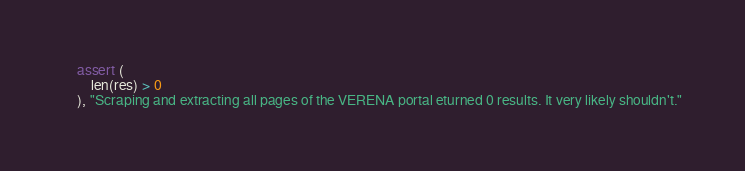Convert code to text. <code><loc_0><loc_0><loc_500><loc_500><_Python_>    assert (
        len(res) > 0
    ), "Scraping and extracting all pages of the VERENA portal eturned 0 results. It very likely shouldn't."
</code> 